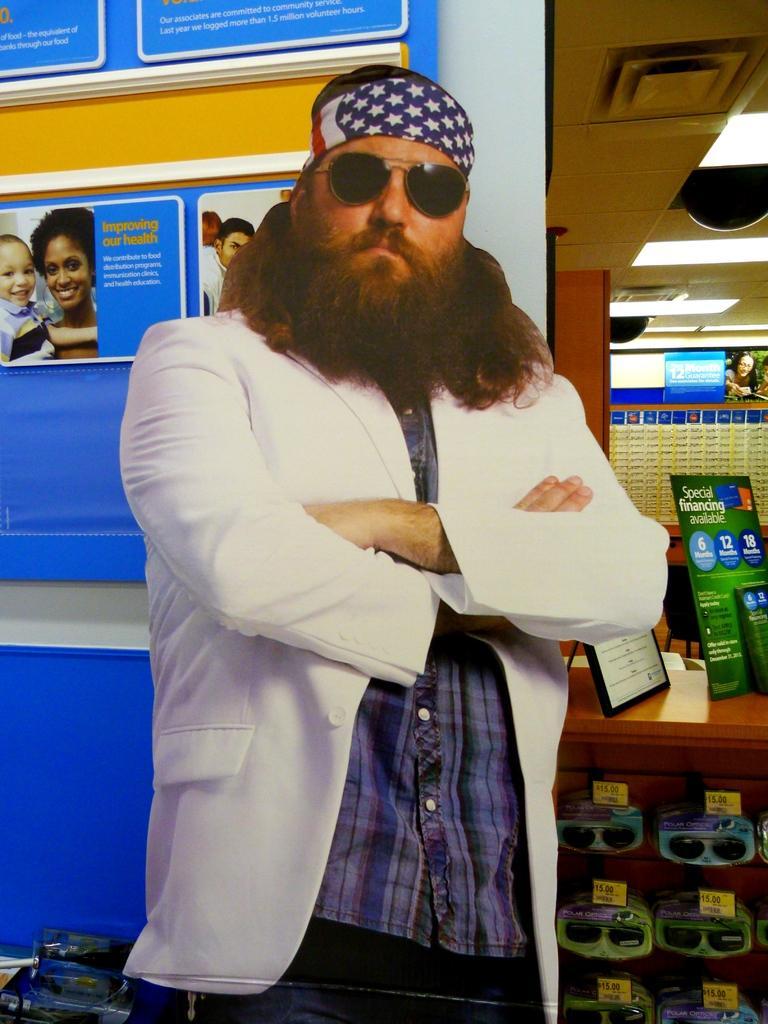In one or two sentences, can you explain what this image depicts? In this image I can see a person wearing white jacket, blue shirt and goggles is standing. In the background I can see the ceiling, few lights to the ceiling, a brown colored table, blue colored boards on the table, few goggles to the table, the white colored wall, few blue colored boards to the wall. 